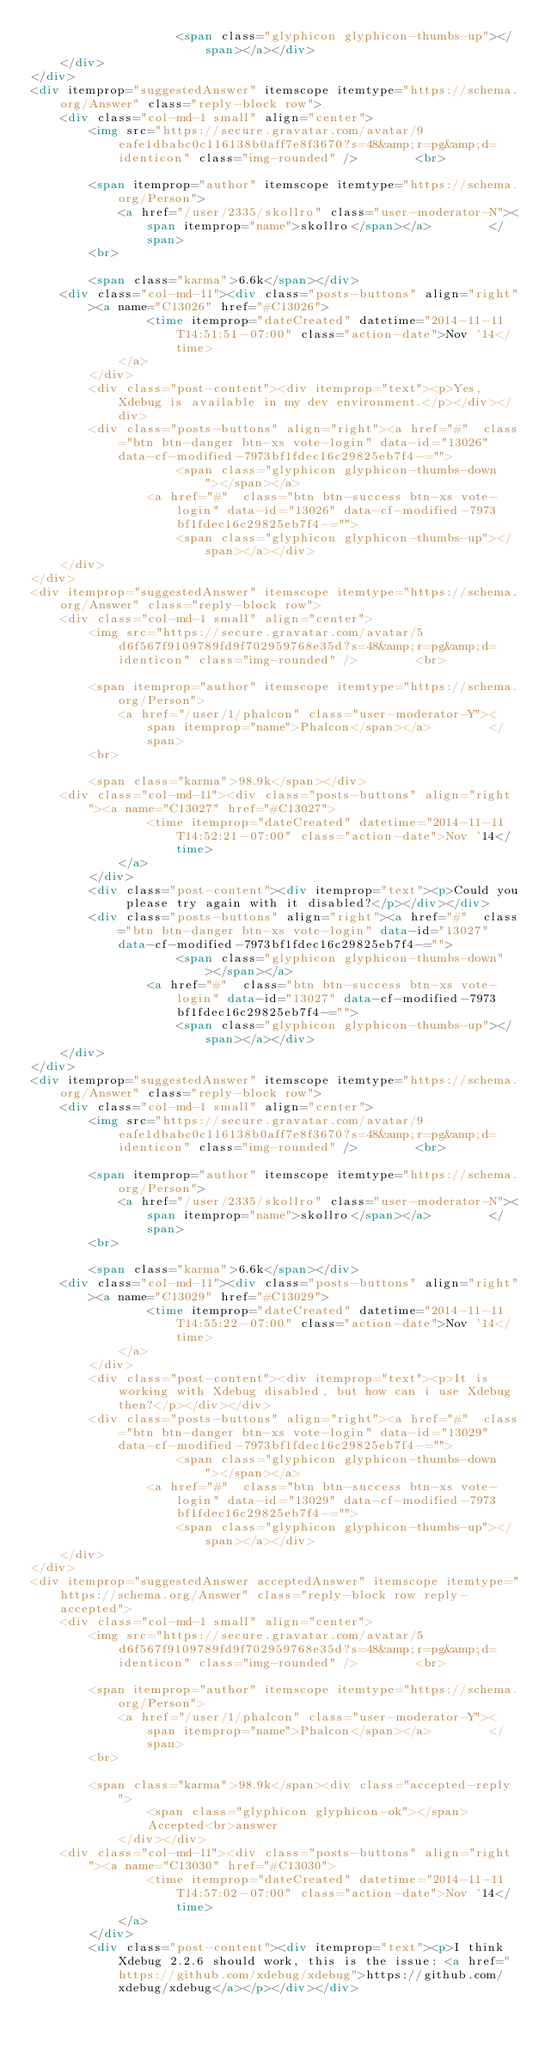<code> <loc_0><loc_0><loc_500><loc_500><_HTML_>                    <span class="glyphicon glyphicon-thumbs-up"></span></a></div>
    </div>
</div>
<div itemprop="suggestedAnswer" itemscope itemtype="https://schema.org/Answer" class="reply-block row">
    <div class="col-md-1 small" align="center">
        <img src="https://secure.gravatar.com/avatar/9eafe1dbabc0c116138b0aff7e8f3670?s=48&amp;r=pg&amp;d=identicon" class="img-rounded" />        <br>

        <span itemprop="author" itemscope itemtype="https://schema.org/Person">
            <a href="/user/2335/skollro" class="user-moderator-N"><span itemprop="name">skollro</span></a>        </span>
        <br>

        <span class="karma">6.6k</span></div>
    <div class="col-md-11"><div class="posts-buttons" align="right"><a name="C13026" href="#C13026">
                <time itemprop="dateCreated" datetime="2014-11-11T14:51:51-07:00" class="action-date">Nov '14</time>
            </a>
        </div>
        <div class="post-content"><div itemprop="text"><p>Yes, Xdebug is available in my dev environment.</p></div></div>
        <div class="posts-buttons" align="right"><a href="#"  class="btn btn-danger btn-xs vote-login" data-id="13026" data-cf-modified-7973bf1fdec16c29825eb7f4-="">
                    <span class="glyphicon glyphicon-thumbs-down"></span></a>
                <a href="#"  class="btn btn-success btn-xs vote-login" data-id="13026" data-cf-modified-7973bf1fdec16c29825eb7f4-="">
                    <span class="glyphicon glyphicon-thumbs-up"></span></a></div>
    </div>
</div>
<div itemprop="suggestedAnswer" itemscope itemtype="https://schema.org/Answer" class="reply-block row">
    <div class="col-md-1 small" align="center">
        <img src="https://secure.gravatar.com/avatar/5d6f567f9109789fd9f702959768e35d?s=48&amp;r=pg&amp;d=identicon" class="img-rounded" />        <br>

        <span itemprop="author" itemscope itemtype="https://schema.org/Person">
            <a href="/user/1/phalcon" class="user-moderator-Y"><span itemprop="name">Phalcon</span></a>        </span>
        <br>

        <span class="karma">98.9k</span></div>
    <div class="col-md-11"><div class="posts-buttons" align="right"><a name="C13027" href="#C13027">
                <time itemprop="dateCreated" datetime="2014-11-11T14:52:21-07:00" class="action-date">Nov '14</time>
            </a>
        </div>
        <div class="post-content"><div itemprop="text"><p>Could you please try again with it disabled?</p></div></div>
        <div class="posts-buttons" align="right"><a href="#"  class="btn btn-danger btn-xs vote-login" data-id="13027" data-cf-modified-7973bf1fdec16c29825eb7f4-="">
                    <span class="glyphicon glyphicon-thumbs-down"></span></a>
                <a href="#"  class="btn btn-success btn-xs vote-login" data-id="13027" data-cf-modified-7973bf1fdec16c29825eb7f4-="">
                    <span class="glyphicon glyphicon-thumbs-up"></span></a></div>
    </div>
</div>
<div itemprop="suggestedAnswer" itemscope itemtype="https://schema.org/Answer" class="reply-block row">
    <div class="col-md-1 small" align="center">
        <img src="https://secure.gravatar.com/avatar/9eafe1dbabc0c116138b0aff7e8f3670?s=48&amp;r=pg&amp;d=identicon" class="img-rounded" />        <br>

        <span itemprop="author" itemscope itemtype="https://schema.org/Person">
            <a href="/user/2335/skollro" class="user-moderator-N"><span itemprop="name">skollro</span></a>        </span>
        <br>

        <span class="karma">6.6k</span></div>
    <div class="col-md-11"><div class="posts-buttons" align="right"><a name="C13029" href="#C13029">
                <time itemprop="dateCreated" datetime="2014-11-11T14:55:22-07:00" class="action-date">Nov '14</time>
            </a>
        </div>
        <div class="post-content"><div itemprop="text"><p>It is working with Xdebug disabled, but how can i use Xdebug then?</p></div></div>
        <div class="posts-buttons" align="right"><a href="#"  class="btn btn-danger btn-xs vote-login" data-id="13029" data-cf-modified-7973bf1fdec16c29825eb7f4-="">
                    <span class="glyphicon glyphicon-thumbs-down"></span></a>
                <a href="#"  class="btn btn-success btn-xs vote-login" data-id="13029" data-cf-modified-7973bf1fdec16c29825eb7f4-="">
                    <span class="glyphicon glyphicon-thumbs-up"></span></a></div>
    </div>
</div>
<div itemprop="suggestedAnswer acceptedAnswer" itemscope itemtype="https://schema.org/Answer" class="reply-block row reply-accepted">
    <div class="col-md-1 small" align="center">
        <img src="https://secure.gravatar.com/avatar/5d6f567f9109789fd9f702959768e35d?s=48&amp;r=pg&amp;d=identicon" class="img-rounded" />        <br>

        <span itemprop="author" itemscope itemtype="https://schema.org/Person">
            <a href="/user/1/phalcon" class="user-moderator-Y"><span itemprop="name">Phalcon</span></a>        </span>
        <br>

        <span class="karma">98.9k</span><div class="accepted-reply">
                <span class="glyphicon glyphicon-ok"></span>
                Accepted<br>answer
            </div></div>
    <div class="col-md-11"><div class="posts-buttons" align="right"><a name="C13030" href="#C13030">
                <time itemprop="dateCreated" datetime="2014-11-11T14:57:02-07:00" class="action-date">Nov '14</time>
            </a>
        </div>
        <div class="post-content"><div itemprop="text"><p>I think Xdebug 2.2.6 should work, this is the issue: <a href="https://github.com/xdebug/xdebug">https://github.com/xdebug/xdebug</a></p></div></div></code> 